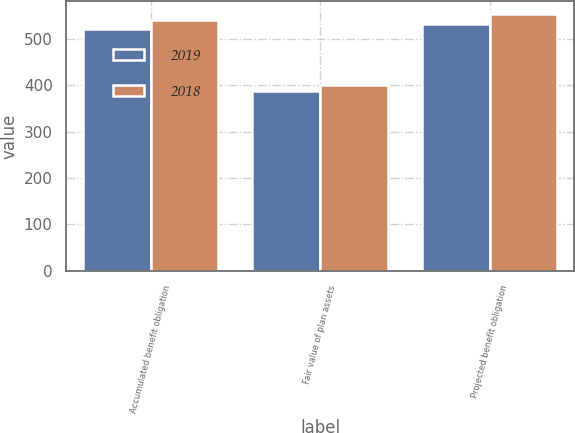<chart> <loc_0><loc_0><loc_500><loc_500><stacked_bar_chart><ecel><fcel>Accumulated benefit obligation<fcel>Fair value of plan assets<fcel>Projected benefit obligation<nl><fcel>2019<fcel>521.5<fcel>388.2<fcel>531.4<nl><fcel>2018<fcel>541.3<fcel>400.6<fcel>552.9<nl></chart> 